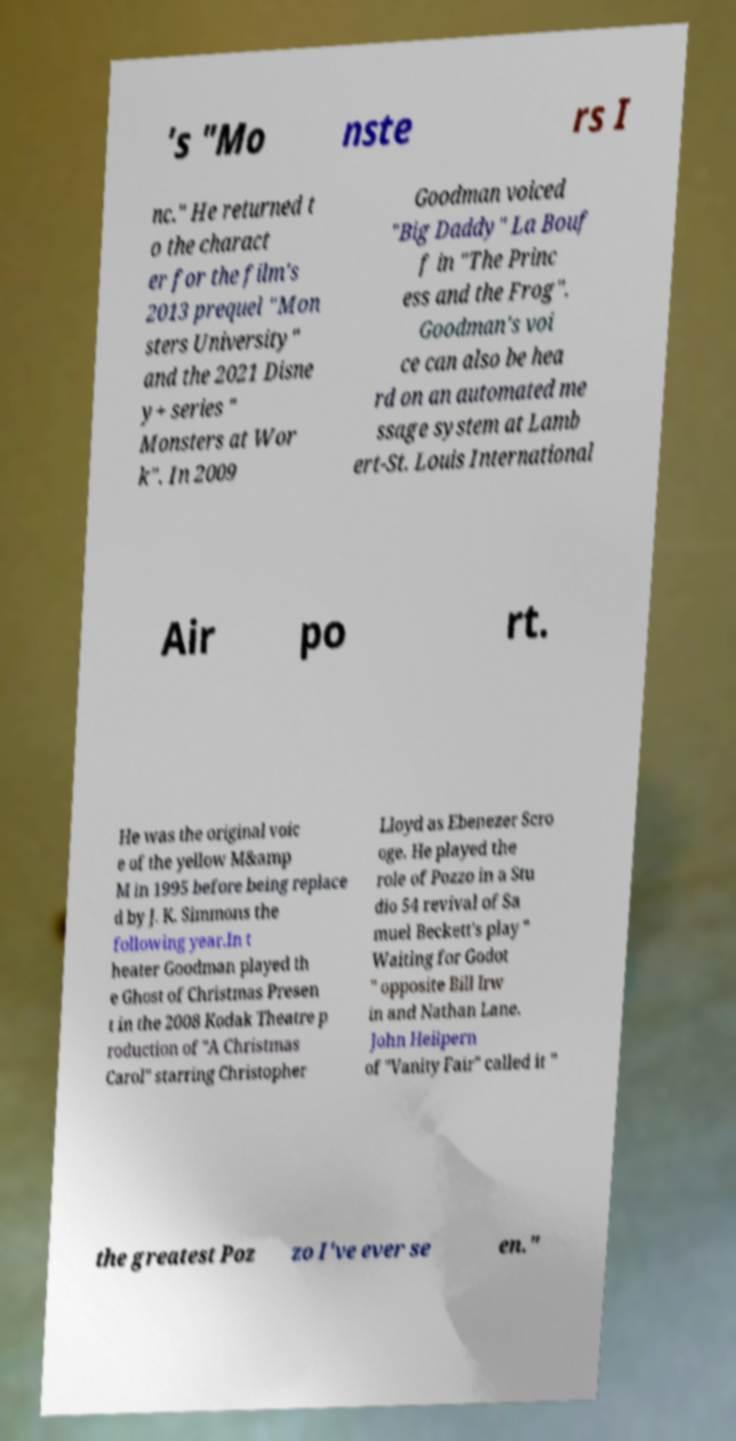Please read and relay the text visible in this image. What does it say? 's "Mo nste rs I nc." He returned t o the charact er for the film's 2013 prequel "Mon sters University" and the 2021 Disne y+ series " Monsters at Wor k". In 2009 Goodman voiced "Big Daddy" La Bouf f in "The Princ ess and the Frog". Goodman's voi ce can also be hea rd on an automated me ssage system at Lamb ert-St. Louis International Air po rt. He was the original voic e of the yellow M&amp M in 1995 before being replace d by J. K. Simmons the following year.In t heater Goodman played th e Ghost of Christmas Presen t in the 2008 Kodak Theatre p roduction of "A Christmas Carol" starring Christopher Lloyd as Ebenezer Scro oge. He played the role of Pozzo in a Stu dio 54 revival of Sa muel Beckett's play " Waiting for Godot " opposite Bill Irw in and Nathan Lane. John Heilpern of "Vanity Fair" called it " the greatest Poz zo I've ever se en." 